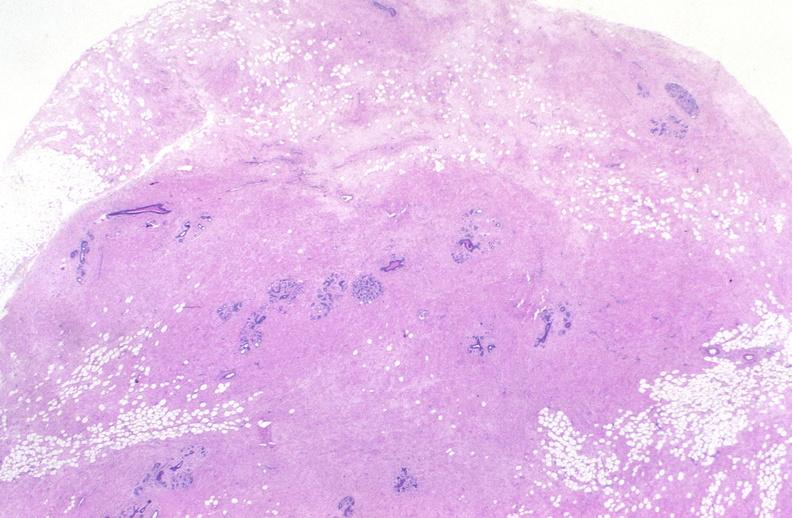where is this area in the body?
Answer the question using a single word or phrase. Breast 